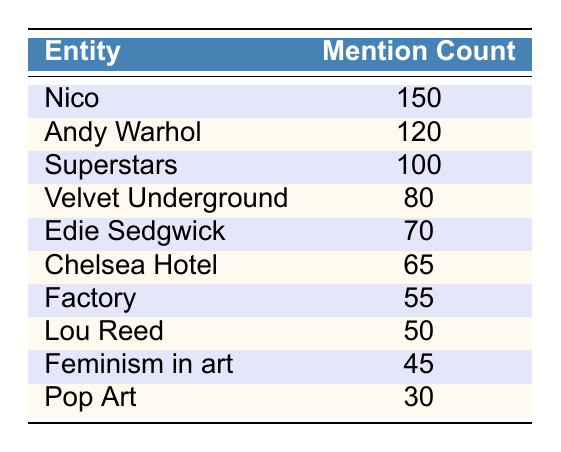What is the mention count for Nico? The table shows the mention count for Nico directly listed under the 'Mention Count' column. The value given is 150.
Answer: 150 How many more mentions does Andy Warhol have compared to Lou Reed? From the table, Andy Warhol has a mention count of 120 and Lou Reed has a mention count of 50. To find the difference, subtract Lou Reed's count from Andy Warhol's: 120 - 50 = 70.
Answer: 70 True or false: The mention count for Velvet Underground is greater than that of Chelsea Hotel. Velvet Underground has a mention count of 80, while Chelsea Hotel has a mention count of 65. Since 80 is greater than 65, the statement is true.
Answer: True What is the total mention count for Nico and Edie Sedgwick combined? From the table, Nico has a mention count of 150 and Edie Sedgwick has a mention count of 70. To find the total, add the two counts together: 150 + 70 = 220.
Answer: 220 Which entity has the lowest mention count? The table lists the mention counts for various entities, and the lowest value is found under the Pop Art entity, which has a mention count of 30.
Answer: Pop Art What is the average mention count of the top three entities mentioned? The top three entities are Nico (150), Andy Warhol (120), and Superstars (100). To find the average, sum their counts: 150 + 120 + 100 = 370, then divide by 3: 370 / 3 = 123.33, which can be rounded as needed.
Answer: 123.33 Is there any entity that has a mention count of exactly 45? The table shows mention counts for various entities, and the value of 45 is associated with 'Feminism in art'. Thus there is indeed an entity with that mention count.
Answer: Yes What is the difference in mention count between Superstars and the Factory? Superstars has a mention count of 100, while the Factory has a mention count of 55. To find the difference, subtract the Factory's count from Superstars' count: 100 - 55 = 45.
Answer: 45 How many total mentions do Nico, Edie Sedgwick, and Feminism in art have? The counts for Nico, Edie Sedgwick, and Feminism in art are 150, 70, and 45 respectively. Summing these gives: 150 + 70 + 45 = 265.
Answer: 265 